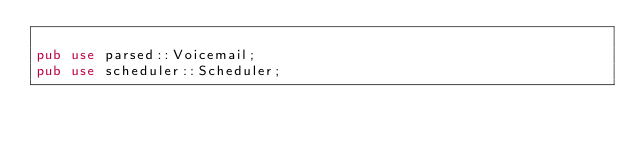<code> <loc_0><loc_0><loc_500><loc_500><_Rust_>
pub use parsed::Voicemail;
pub use scheduler::Scheduler;
</code> 